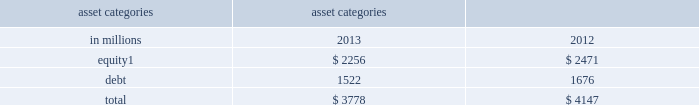Management 2019s discussion and analysis sensitivity measures certain portfolios and individual positions are not included in var because var is not the most appropriate risk measure .
Other sensitivity measures we use to analyze market risk are described below .
10% ( 10 % ) sensitivity measures .
The table below presents market risk for inventory positions that are not included in var .
The market risk of these positions is determined by estimating the potential reduction in net revenues of a 10% ( 10 % ) decline in the underlying asset value .
Equity positions below relate to private and restricted public equity securities , including interests in funds that invest in corporate equities and real estate and interests in hedge funds , which are included in 201cfinancial instruments owned , at fair value . 201d debt positions include interests in funds that invest in corporate mezzanine and senior debt instruments , loans backed by commercial and residential real estate , corporate bank loans and other corporate debt , including acquired portfolios of distressed loans .
These debt positions are included in 201cfinancial instruments owned , at fair value . 201d see note 6 to the consolidated financial statements for further information about cash instruments .
These measures do not reflect diversification benefits across asset categories or across other market risk measures .
Asset categories 10% ( 10 % ) sensitivity amount as of december in millions 2013 2012 equity 1 $ 2256 $ 2471 .
December 2012 includes $ 208 million related to our investment in the ordinary shares of icbc , which was sold in the first half of 2013 .
Credit spread sensitivity on derivatives and borrowings .
Var excludes the impact of changes in counterparty and our own credit spreads on derivatives as well as changes in our own credit spreads on unsecured borrowings for which the fair value option was elected .
The estimated sensitivity to a one basis point increase in credit spreads ( counterparty and our own ) on derivatives was a gain of $ 4 million and $ 3 million ( including hedges ) as of december 2013 and december 2012 , respectively .
In addition , the estimated sensitivity to a one basis point increase in our own credit spreads on unsecured borrowings for which the fair value option was elected was a gain of $ 8 million and $ 7 million ( including hedges ) as of december 2013 and december 2012 , respectively .
However , the actual net impact of a change in our own credit spreads is also affected by the liquidity , duration and convexity ( as the sensitivity is not linear to changes in yields ) of those unsecured borrowings for which the fair value option was elected , as well as the relative performance of any hedges undertaken .
Interest rate sensitivity .
As of december 2013 and december 2012 , the firm had $ 14.90 billion and $ 6.50 billion , respectively , of loans held for investment which were accounted for at amortized cost and included in 201creceivables from customers and counterparties , 201d substantially all of which had floating interest rates .
As of december 2013 and december 2012 , the estimated sensitivity to a 100 basis point increase in interest rates on such loans was $ 136 million and $ 62 million , respectively , of additional interest income over a 12-month period , which does not take into account the potential impact of an increase in costs to fund such loans .
See note 8 to the consolidated financial statements for further information about loans held for investment .
Goldman sachs 2013 annual report 95 .
What percentage of total 10% ( 10 % ) sensitivity amount as of december 2013 is equity related? 
Computations: (2256 / 3778)
Answer: 0.59714. Management 2019s discussion and analysis sensitivity measures certain portfolios and individual positions are not included in var because var is not the most appropriate risk measure .
Other sensitivity measures we use to analyze market risk are described below .
10% ( 10 % ) sensitivity measures .
The table below presents market risk for inventory positions that are not included in var .
The market risk of these positions is determined by estimating the potential reduction in net revenues of a 10% ( 10 % ) decline in the underlying asset value .
Equity positions below relate to private and restricted public equity securities , including interests in funds that invest in corporate equities and real estate and interests in hedge funds , which are included in 201cfinancial instruments owned , at fair value . 201d debt positions include interests in funds that invest in corporate mezzanine and senior debt instruments , loans backed by commercial and residential real estate , corporate bank loans and other corporate debt , including acquired portfolios of distressed loans .
These debt positions are included in 201cfinancial instruments owned , at fair value . 201d see note 6 to the consolidated financial statements for further information about cash instruments .
These measures do not reflect diversification benefits across asset categories or across other market risk measures .
Asset categories 10% ( 10 % ) sensitivity amount as of december in millions 2013 2012 equity 1 $ 2256 $ 2471 .
December 2012 includes $ 208 million related to our investment in the ordinary shares of icbc , which was sold in the first half of 2013 .
Credit spread sensitivity on derivatives and borrowings .
Var excludes the impact of changes in counterparty and our own credit spreads on derivatives as well as changes in our own credit spreads on unsecured borrowings for which the fair value option was elected .
The estimated sensitivity to a one basis point increase in credit spreads ( counterparty and our own ) on derivatives was a gain of $ 4 million and $ 3 million ( including hedges ) as of december 2013 and december 2012 , respectively .
In addition , the estimated sensitivity to a one basis point increase in our own credit spreads on unsecured borrowings for which the fair value option was elected was a gain of $ 8 million and $ 7 million ( including hedges ) as of december 2013 and december 2012 , respectively .
However , the actual net impact of a change in our own credit spreads is also affected by the liquidity , duration and convexity ( as the sensitivity is not linear to changes in yields ) of those unsecured borrowings for which the fair value option was elected , as well as the relative performance of any hedges undertaken .
Interest rate sensitivity .
As of december 2013 and december 2012 , the firm had $ 14.90 billion and $ 6.50 billion , respectively , of loans held for investment which were accounted for at amortized cost and included in 201creceivables from customers and counterparties , 201d substantially all of which had floating interest rates .
As of december 2013 and december 2012 , the estimated sensitivity to a 100 basis point increase in interest rates on such loans was $ 136 million and $ 62 million , respectively , of additional interest income over a 12-month period , which does not take into account the potential impact of an increase in costs to fund such loans .
See note 8 to the consolidated financial statements for further information about loans held for investment .
Goldman sachs 2013 annual report 95 .
For 2012 , what was the percentage of the equity related to our investment in the ordinary shares of icbc , which was sold in the first half of 2013? 
Computations: (208 / 2471)
Answer: 0.08418. Management 2019s discussion and analysis sensitivity measures certain portfolios and individual positions are not included in var because var is not the most appropriate risk measure .
Other sensitivity measures we use to analyze market risk are described below .
10% ( 10 % ) sensitivity measures .
The table below presents market risk for inventory positions that are not included in var .
The market risk of these positions is determined by estimating the potential reduction in net revenues of a 10% ( 10 % ) decline in the underlying asset value .
Equity positions below relate to private and restricted public equity securities , including interests in funds that invest in corporate equities and real estate and interests in hedge funds , which are included in 201cfinancial instruments owned , at fair value . 201d debt positions include interests in funds that invest in corporate mezzanine and senior debt instruments , loans backed by commercial and residential real estate , corporate bank loans and other corporate debt , including acquired portfolios of distressed loans .
These debt positions are included in 201cfinancial instruments owned , at fair value . 201d see note 6 to the consolidated financial statements for further information about cash instruments .
These measures do not reflect diversification benefits across asset categories or across other market risk measures .
Asset categories 10% ( 10 % ) sensitivity amount as of december in millions 2013 2012 equity 1 $ 2256 $ 2471 .
December 2012 includes $ 208 million related to our investment in the ordinary shares of icbc , which was sold in the first half of 2013 .
Credit spread sensitivity on derivatives and borrowings .
Var excludes the impact of changes in counterparty and our own credit spreads on derivatives as well as changes in our own credit spreads on unsecured borrowings for which the fair value option was elected .
The estimated sensitivity to a one basis point increase in credit spreads ( counterparty and our own ) on derivatives was a gain of $ 4 million and $ 3 million ( including hedges ) as of december 2013 and december 2012 , respectively .
In addition , the estimated sensitivity to a one basis point increase in our own credit spreads on unsecured borrowings for which the fair value option was elected was a gain of $ 8 million and $ 7 million ( including hedges ) as of december 2013 and december 2012 , respectively .
However , the actual net impact of a change in our own credit spreads is also affected by the liquidity , duration and convexity ( as the sensitivity is not linear to changes in yields ) of those unsecured borrowings for which the fair value option was elected , as well as the relative performance of any hedges undertaken .
Interest rate sensitivity .
As of december 2013 and december 2012 , the firm had $ 14.90 billion and $ 6.50 billion , respectively , of loans held for investment which were accounted for at amortized cost and included in 201creceivables from customers and counterparties , 201d substantially all of which had floating interest rates .
As of december 2013 and december 2012 , the estimated sensitivity to a 100 basis point increase in interest rates on such loans was $ 136 million and $ 62 million , respectively , of additional interest income over a 12-month period , which does not take into account the potential impact of an increase in costs to fund such loans .
See note 8 to the consolidated financial statements for further information about loans held for investment .
Goldman sachs 2013 annual report 95 .
What percentage of total 10% ( 10 % ) sensitivity amount as of december 2012 is equity related? 
Computations: (2471 / 4147)
Answer: 0.59585. 